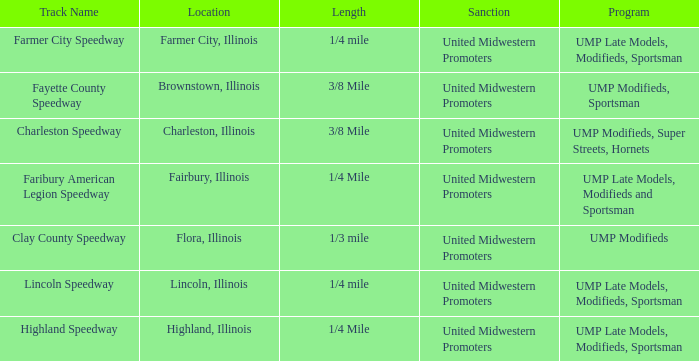What programs were held in charleston, illinois? UMP Modifieds, Super Streets, Hornets. 